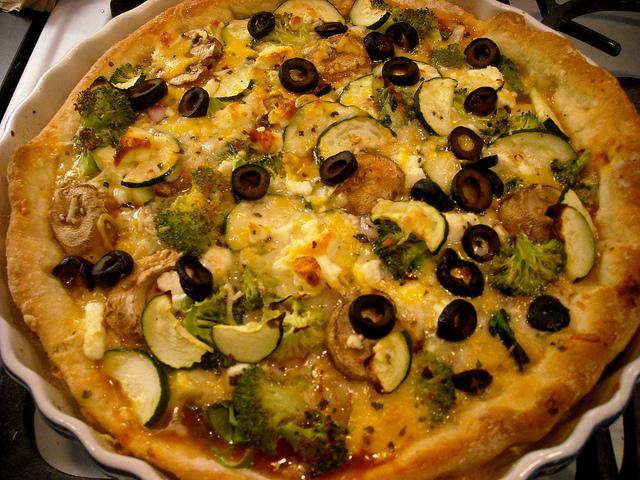Is this pizza vegetarian?
Write a very short answer. Yes. Are there any mushrooms on the pizza?
Short answer required. Yes. Is the bowl fluted?
Short answer required. Yes. 